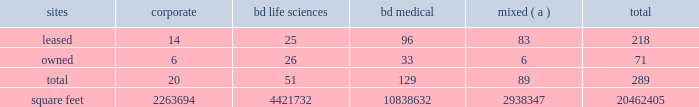Item 2 .
Properties .
Bd 2019s executive offices are located in franklin lakes , new jersey .
As of october 31 , 2017 , bd owned or leased 289 facilities throughout the world , comprising approximately 20462405 square feet of manufacturing , warehousing , administrative and research facilities .
The u.s .
Facilities , including those in puerto rico , comprise approximately 7472419 square feet of owned and 2976267 square feet of leased space .
The international facilities comprise approximately 7478714 square feet of owned and 2535005 square feet of leased space .
Sales offices and distribution centers included in the total square footage are also located throughout the world .
Operations in each of bd 2019s business segments are conducted at both u.s .
And international locations .
Particularly in the international marketplace , facilities often serve more than one business segment and are used for multiple purposes , such as administrative/sales , manufacturing and/or warehousing/distribution .
Bd generally seeks to own its manufacturing facilities , although some are leased .
The table summarizes property information by business segment. .
( a ) facilities used by more than one business segment .
Bd believes that its facilities are of good construction and in good physical condition , are suitable and adequate for the operations conducted at those facilities , and are , with minor exceptions , fully utilized and operating at normal capacity .
The u.s .
Facilities are located in alabama , arizona , california , connecticut , florida , georgia , illinois , indiana , maryland , massachusetts , michigan , missouri , nebraska , new jersey , north carolina , ohio , oklahoma , south carolina , texas , utah , virginia , washington , d.c. , washington , wisconsin and puerto rico .
The international facilities are as follows : - europe , middle east , africa , which includes facilities in austria , belgium , bosnia and herzegovina , the czech republic , denmark , england , finland , france , germany , ghana , hungary , ireland , israel , italy , kenya , luxembourg , netherlands , norway , poland , portugal , russia , saudi arabia , south africa , spain , sweden , switzerland , turkey , the united arab emirates and zambia .
- greater asia , which includes facilities in australia , bangladesh , china , india , indonesia , japan , malaysia , new zealand , the philippines , singapore , south korea , taiwan , thailand and vietnam .
- latin america , which includes facilities in argentina , brazil , chile , colombia , mexico , peru and the dominican republic .
- canada .
Item 3 .
Legal proceedings .
Information with respect to certain legal proceedings is included in note 5 to the consolidated financial statements contained in item 8 .
Financial statements and supplementary data , and is incorporated herein by reference .
Item 4 .
Mine safety disclosures .
Not applicable. .
What percentage of mixed use units are owned? 
Computations: (6 / 89)
Answer: 0.06742. 